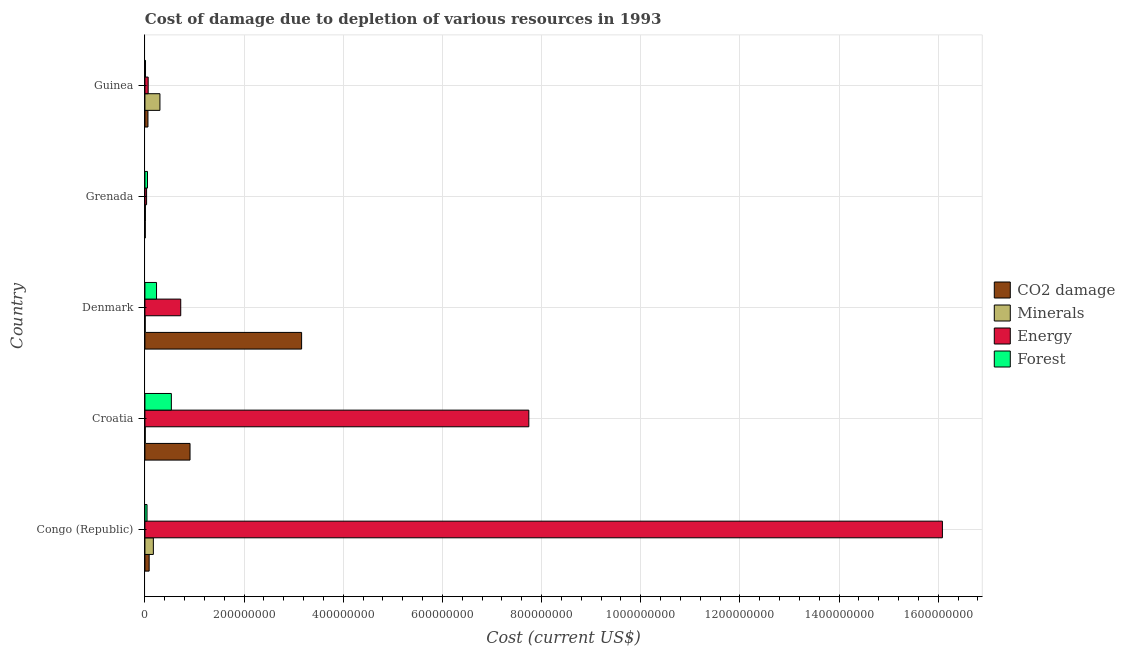How many groups of bars are there?
Provide a succinct answer. 5. Are the number of bars on each tick of the Y-axis equal?
Provide a succinct answer. Yes. How many bars are there on the 2nd tick from the top?
Provide a succinct answer. 4. How many bars are there on the 3rd tick from the bottom?
Offer a very short reply. 4. What is the label of the 5th group of bars from the top?
Your answer should be very brief. Congo (Republic). In how many cases, is the number of bars for a given country not equal to the number of legend labels?
Make the answer very short. 0. What is the cost of damage due to depletion of energy in Denmark?
Provide a succinct answer. 7.22e+07. Across all countries, what is the maximum cost of damage due to depletion of forests?
Ensure brevity in your answer.  5.33e+07. Across all countries, what is the minimum cost of damage due to depletion of forests?
Ensure brevity in your answer.  1.22e+06. In which country was the cost of damage due to depletion of minerals maximum?
Provide a succinct answer. Guinea. In which country was the cost of damage due to depletion of minerals minimum?
Your response must be concise. Denmark. What is the total cost of damage due to depletion of energy in the graph?
Offer a very short reply. 2.46e+09. What is the difference between the cost of damage due to depletion of coal in Congo (Republic) and that in Denmark?
Your answer should be very brief. -3.07e+08. What is the difference between the cost of damage due to depletion of forests in Grenada and the cost of damage due to depletion of energy in Denmark?
Keep it short and to the point. -6.70e+07. What is the average cost of damage due to depletion of energy per country?
Offer a terse response. 4.93e+08. What is the difference between the cost of damage due to depletion of forests and cost of damage due to depletion of energy in Grenada?
Offer a very short reply. 1.84e+06. In how many countries, is the cost of damage due to depletion of coal greater than 1160000000 US$?
Ensure brevity in your answer.  0. What is the ratio of the cost of damage due to depletion of minerals in Congo (Republic) to that in Guinea?
Make the answer very short. 0.56. What is the difference between the highest and the second highest cost of damage due to depletion of coal?
Give a very brief answer. 2.25e+08. What is the difference between the highest and the lowest cost of damage due to depletion of coal?
Provide a succinct answer. 3.15e+08. In how many countries, is the cost of damage due to depletion of coal greater than the average cost of damage due to depletion of coal taken over all countries?
Offer a terse response. 2. Is the sum of the cost of damage due to depletion of minerals in Grenada and Guinea greater than the maximum cost of damage due to depletion of forests across all countries?
Give a very brief answer. No. Is it the case that in every country, the sum of the cost of damage due to depletion of energy and cost of damage due to depletion of minerals is greater than the sum of cost of damage due to depletion of forests and cost of damage due to depletion of coal?
Keep it short and to the point. No. What does the 3rd bar from the top in Guinea represents?
Your response must be concise. Minerals. What does the 4th bar from the bottom in Denmark represents?
Your response must be concise. Forest. Is it the case that in every country, the sum of the cost of damage due to depletion of coal and cost of damage due to depletion of minerals is greater than the cost of damage due to depletion of energy?
Provide a succinct answer. No. How many bars are there?
Provide a short and direct response. 20. How many countries are there in the graph?
Provide a short and direct response. 5. Are the values on the major ticks of X-axis written in scientific E-notation?
Your answer should be compact. No. Does the graph contain any zero values?
Give a very brief answer. No. Does the graph contain grids?
Make the answer very short. Yes. How are the legend labels stacked?
Keep it short and to the point. Vertical. What is the title of the graph?
Keep it short and to the point. Cost of damage due to depletion of various resources in 1993 . What is the label or title of the X-axis?
Your answer should be compact. Cost (current US$). What is the label or title of the Y-axis?
Keep it short and to the point. Country. What is the Cost (current US$) in CO2 damage in Congo (Republic)?
Your answer should be compact. 8.55e+06. What is the Cost (current US$) in Minerals in Congo (Republic)?
Provide a succinct answer. 1.70e+07. What is the Cost (current US$) of Energy in Congo (Republic)?
Make the answer very short. 1.61e+09. What is the Cost (current US$) of Forest in Congo (Republic)?
Offer a very short reply. 4.27e+06. What is the Cost (current US$) of CO2 damage in Croatia?
Your answer should be very brief. 9.10e+07. What is the Cost (current US$) of Minerals in Croatia?
Keep it short and to the point. 6.66e+05. What is the Cost (current US$) of Energy in Croatia?
Offer a very short reply. 7.74e+08. What is the Cost (current US$) of Forest in Croatia?
Provide a short and direct response. 5.33e+07. What is the Cost (current US$) of CO2 damage in Denmark?
Your answer should be compact. 3.16e+08. What is the Cost (current US$) of Minerals in Denmark?
Give a very brief answer. 5.69e+05. What is the Cost (current US$) in Energy in Denmark?
Ensure brevity in your answer.  7.22e+07. What is the Cost (current US$) in Forest in Denmark?
Provide a succinct answer. 2.34e+07. What is the Cost (current US$) of CO2 damage in Grenada?
Provide a succinct answer. 6.90e+05. What is the Cost (current US$) of Minerals in Grenada?
Provide a short and direct response. 9.67e+05. What is the Cost (current US$) in Energy in Grenada?
Ensure brevity in your answer.  3.37e+06. What is the Cost (current US$) of Forest in Grenada?
Your answer should be compact. 5.21e+06. What is the Cost (current US$) in CO2 damage in Guinea?
Provide a short and direct response. 6.11e+06. What is the Cost (current US$) in Minerals in Guinea?
Provide a succinct answer. 3.03e+07. What is the Cost (current US$) in Energy in Guinea?
Your answer should be very brief. 6.56e+06. What is the Cost (current US$) of Forest in Guinea?
Make the answer very short. 1.22e+06. Across all countries, what is the maximum Cost (current US$) of CO2 damage?
Make the answer very short. 3.16e+08. Across all countries, what is the maximum Cost (current US$) in Minerals?
Make the answer very short. 3.03e+07. Across all countries, what is the maximum Cost (current US$) of Energy?
Your answer should be compact. 1.61e+09. Across all countries, what is the maximum Cost (current US$) in Forest?
Provide a short and direct response. 5.33e+07. Across all countries, what is the minimum Cost (current US$) of CO2 damage?
Provide a short and direct response. 6.90e+05. Across all countries, what is the minimum Cost (current US$) of Minerals?
Offer a terse response. 5.69e+05. Across all countries, what is the minimum Cost (current US$) in Energy?
Provide a succinct answer. 3.37e+06. Across all countries, what is the minimum Cost (current US$) in Forest?
Make the answer very short. 1.22e+06. What is the total Cost (current US$) of CO2 damage in the graph?
Offer a very short reply. 4.22e+08. What is the total Cost (current US$) in Minerals in the graph?
Your answer should be compact. 4.95e+07. What is the total Cost (current US$) in Energy in the graph?
Provide a short and direct response. 2.46e+09. What is the total Cost (current US$) in Forest in the graph?
Keep it short and to the point. 8.74e+07. What is the difference between the Cost (current US$) of CO2 damage in Congo (Republic) and that in Croatia?
Keep it short and to the point. -8.24e+07. What is the difference between the Cost (current US$) of Minerals in Congo (Republic) and that in Croatia?
Give a very brief answer. 1.63e+07. What is the difference between the Cost (current US$) in Energy in Congo (Republic) and that in Croatia?
Make the answer very short. 8.34e+08. What is the difference between the Cost (current US$) of Forest in Congo (Republic) and that in Croatia?
Make the answer very short. -4.90e+07. What is the difference between the Cost (current US$) in CO2 damage in Congo (Republic) and that in Denmark?
Keep it short and to the point. -3.07e+08. What is the difference between the Cost (current US$) in Minerals in Congo (Republic) and that in Denmark?
Ensure brevity in your answer.  1.64e+07. What is the difference between the Cost (current US$) of Energy in Congo (Republic) and that in Denmark?
Your answer should be very brief. 1.54e+09. What is the difference between the Cost (current US$) of Forest in Congo (Republic) and that in Denmark?
Provide a succinct answer. -1.91e+07. What is the difference between the Cost (current US$) in CO2 damage in Congo (Republic) and that in Grenada?
Provide a succinct answer. 7.86e+06. What is the difference between the Cost (current US$) in Minerals in Congo (Republic) and that in Grenada?
Keep it short and to the point. 1.60e+07. What is the difference between the Cost (current US$) of Energy in Congo (Republic) and that in Grenada?
Give a very brief answer. 1.60e+09. What is the difference between the Cost (current US$) in Forest in Congo (Republic) and that in Grenada?
Offer a terse response. -9.36e+05. What is the difference between the Cost (current US$) of CO2 damage in Congo (Republic) and that in Guinea?
Your answer should be compact. 2.44e+06. What is the difference between the Cost (current US$) in Minerals in Congo (Republic) and that in Guinea?
Your answer should be very brief. -1.33e+07. What is the difference between the Cost (current US$) of Energy in Congo (Republic) and that in Guinea?
Provide a short and direct response. 1.60e+09. What is the difference between the Cost (current US$) of Forest in Congo (Republic) and that in Guinea?
Give a very brief answer. 3.06e+06. What is the difference between the Cost (current US$) of CO2 damage in Croatia and that in Denmark?
Provide a succinct answer. -2.25e+08. What is the difference between the Cost (current US$) of Minerals in Croatia and that in Denmark?
Provide a succinct answer. 9.76e+04. What is the difference between the Cost (current US$) in Energy in Croatia and that in Denmark?
Your answer should be compact. 7.02e+08. What is the difference between the Cost (current US$) of Forest in Croatia and that in Denmark?
Ensure brevity in your answer.  2.99e+07. What is the difference between the Cost (current US$) in CO2 damage in Croatia and that in Grenada?
Make the answer very short. 9.03e+07. What is the difference between the Cost (current US$) of Minerals in Croatia and that in Grenada?
Give a very brief answer. -3.01e+05. What is the difference between the Cost (current US$) of Energy in Croatia and that in Grenada?
Offer a very short reply. 7.71e+08. What is the difference between the Cost (current US$) of Forest in Croatia and that in Grenada?
Provide a short and direct response. 4.81e+07. What is the difference between the Cost (current US$) of CO2 damage in Croatia and that in Guinea?
Make the answer very short. 8.49e+07. What is the difference between the Cost (current US$) of Minerals in Croatia and that in Guinea?
Offer a terse response. -2.96e+07. What is the difference between the Cost (current US$) in Energy in Croatia and that in Guinea?
Your answer should be very brief. 7.68e+08. What is the difference between the Cost (current US$) in Forest in Croatia and that in Guinea?
Provide a succinct answer. 5.21e+07. What is the difference between the Cost (current US$) in CO2 damage in Denmark and that in Grenada?
Offer a terse response. 3.15e+08. What is the difference between the Cost (current US$) in Minerals in Denmark and that in Grenada?
Offer a very short reply. -3.98e+05. What is the difference between the Cost (current US$) of Energy in Denmark and that in Grenada?
Keep it short and to the point. 6.89e+07. What is the difference between the Cost (current US$) in Forest in Denmark and that in Grenada?
Give a very brief answer. 1.82e+07. What is the difference between the Cost (current US$) in CO2 damage in Denmark and that in Guinea?
Ensure brevity in your answer.  3.10e+08. What is the difference between the Cost (current US$) in Minerals in Denmark and that in Guinea?
Make the answer very short. -2.97e+07. What is the difference between the Cost (current US$) in Energy in Denmark and that in Guinea?
Keep it short and to the point. 6.57e+07. What is the difference between the Cost (current US$) of Forest in Denmark and that in Guinea?
Give a very brief answer. 2.22e+07. What is the difference between the Cost (current US$) in CO2 damage in Grenada and that in Guinea?
Make the answer very short. -5.42e+06. What is the difference between the Cost (current US$) of Minerals in Grenada and that in Guinea?
Your answer should be very brief. -2.93e+07. What is the difference between the Cost (current US$) in Energy in Grenada and that in Guinea?
Your answer should be compact. -3.19e+06. What is the difference between the Cost (current US$) in Forest in Grenada and that in Guinea?
Your answer should be very brief. 3.99e+06. What is the difference between the Cost (current US$) of CO2 damage in Congo (Republic) and the Cost (current US$) of Minerals in Croatia?
Make the answer very short. 7.88e+06. What is the difference between the Cost (current US$) in CO2 damage in Congo (Republic) and the Cost (current US$) in Energy in Croatia?
Offer a terse response. -7.66e+08. What is the difference between the Cost (current US$) in CO2 damage in Congo (Republic) and the Cost (current US$) in Forest in Croatia?
Your answer should be very brief. -4.48e+07. What is the difference between the Cost (current US$) in Minerals in Congo (Republic) and the Cost (current US$) in Energy in Croatia?
Your answer should be very brief. -7.57e+08. What is the difference between the Cost (current US$) of Minerals in Congo (Republic) and the Cost (current US$) of Forest in Croatia?
Make the answer very short. -3.63e+07. What is the difference between the Cost (current US$) of Energy in Congo (Republic) and the Cost (current US$) of Forest in Croatia?
Make the answer very short. 1.55e+09. What is the difference between the Cost (current US$) in CO2 damage in Congo (Republic) and the Cost (current US$) in Minerals in Denmark?
Provide a succinct answer. 7.98e+06. What is the difference between the Cost (current US$) in CO2 damage in Congo (Republic) and the Cost (current US$) in Energy in Denmark?
Provide a succinct answer. -6.37e+07. What is the difference between the Cost (current US$) in CO2 damage in Congo (Republic) and the Cost (current US$) in Forest in Denmark?
Give a very brief answer. -1.49e+07. What is the difference between the Cost (current US$) of Minerals in Congo (Republic) and the Cost (current US$) of Energy in Denmark?
Provide a short and direct response. -5.52e+07. What is the difference between the Cost (current US$) of Minerals in Congo (Republic) and the Cost (current US$) of Forest in Denmark?
Offer a very short reply. -6.41e+06. What is the difference between the Cost (current US$) of Energy in Congo (Republic) and the Cost (current US$) of Forest in Denmark?
Offer a terse response. 1.58e+09. What is the difference between the Cost (current US$) in CO2 damage in Congo (Republic) and the Cost (current US$) in Minerals in Grenada?
Give a very brief answer. 7.58e+06. What is the difference between the Cost (current US$) in CO2 damage in Congo (Republic) and the Cost (current US$) in Energy in Grenada?
Provide a short and direct response. 5.18e+06. What is the difference between the Cost (current US$) of CO2 damage in Congo (Republic) and the Cost (current US$) of Forest in Grenada?
Provide a short and direct response. 3.34e+06. What is the difference between the Cost (current US$) of Minerals in Congo (Republic) and the Cost (current US$) of Energy in Grenada?
Your answer should be compact. 1.36e+07. What is the difference between the Cost (current US$) of Minerals in Congo (Republic) and the Cost (current US$) of Forest in Grenada?
Your response must be concise. 1.18e+07. What is the difference between the Cost (current US$) of Energy in Congo (Republic) and the Cost (current US$) of Forest in Grenada?
Your answer should be very brief. 1.60e+09. What is the difference between the Cost (current US$) in CO2 damage in Congo (Republic) and the Cost (current US$) in Minerals in Guinea?
Offer a terse response. -2.17e+07. What is the difference between the Cost (current US$) of CO2 damage in Congo (Republic) and the Cost (current US$) of Energy in Guinea?
Keep it short and to the point. 1.99e+06. What is the difference between the Cost (current US$) in CO2 damage in Congo (Republic) and the Cost (current US$) in Forest in Guinea?
Offer a very short reply. 7.33e+06. What is the difference between the Cost (current US$) of Minerals in Congo (Republic) and the Cost (current US$) of Energy in Guinea?
Your answer should be compact. 1.04e+07. What is the difference between the Cost (current US$) in Minerals in Congo (Republic) and the Cost (current US$) in Forest in Guinea?
Offer a terse response. 1.58e+07. What is the difference between the Cost (current US$) in Energy in Congo (Republic) and the Cost (current US$) in Forest in Guinea?
Make the answer very short. 1.61e+09. What is the difference between the Cost (current US$) in CO2 damage in Croatia and the Cost (current US$) in Minerals in Denmark?
Provide a succinct answer. 9.04e+07. What is the difference between the Cost (current US$) in CO2 damage in Croatia and the Cost (current US$) in Energy in Denmark?
Ensure brevity in your answer.  1.87e+07. What is the difference between the Cost (current US$) in CO2 damage in Croatia and the Cost (current US$) in Forest in Denmark?
Offer a terse response. 6.76e+07. What is the difference between the Cost (current US$) of Minerals in Croatia and the Cost (current US$) of Energy in Denmark?
Your response must be concise. -7.16e+07. What is the difference between the Cost (current US$) in Minerals in Croatia and the Cost (current US$) in Forest in Denmark?
Ensure brevity in your answer.  -2.27e+07. What is the difference between the Cost (current US$) in Energy in Croatia and the Cost (current US$) in Forest in Denmark?
Your answer should be compact. 7.51e+08. What is the difference between the Cost (current US$) in CO2 damage in Croatia and the Cost (current US$) in Minerals in Grenada?
Keep it short and to the point. 9.00e+07. What is the difference between the Cost (current US$) in CO2 damage in Croatia and the Cost (current US$) in Energy in Grenada?
Your answer should be compact. 8.76e+07. What is the difference between the Cost (current US$) of CO2 damage in Croatia and the Cost (current US$) of Forest in Grenada?
Your answer should be compact. 8.58e+07. What is the difference between the Cost (current US$) in Minerals in Croatia and the Cost (current US$) in Energy in Grenada?
Keep it short and to the point. -2.70e+06. What is the difference between the Cost (current US$) in Minerals in Croatia and the Cost (current US$) in Forest in Grenada?
Offer a very short reply. -4.54e+06. What is the difference between the Cost (current US$) of Energy in Croatia and the Cost (current US$) of Forest in Grenada?
Offer a very short reply. 7.69e+08. What is the difference between the Cost (current US$) of CO2 damage in Croatia and the Cost (current US$) of Minerals in Guinea?
Your answer should be compact. 6.07e+07. What is the difference between the Cost (current US$) of CO2 damage in Croatia and the Cost (current US$) of Energy in Guinea?
Provide a succinct answer. 8.44e+07. What is the difference between the Cost (current US$) of CO2 damage in Croatia and the Cost (current US$) of Forest in Guinea?
Offer a terse response. 8.97e+07. What is the difference between the Cost (current US$) in Minerals in Croatia and the Cost (current US$) in Energy in Guinea?
Your answer should be compact. -5.89e+06. What is the difference between the Cost (current US$) of Minerals in Croatia and the Cost (current US$) of Forest in Guinea?
Keep it short and to the point. -5.52e+05. What is the difference between the Cost (current US$) of Energy in Croatia and the Cost (current US$) of Forest in Guinea?
Offer a very short reply. 7.73e+08. What is the difference between the Cost (current US$) of CO2 damage in Denmark and the Cost (current US$) of Minerals in Grenada?
Make the answer very short. 3.15e+08. What is the difference between the Cost (current US$) of CO2 damage in Denmark and the Cost (current US$) of Energy in Grenada?
Offer a very short reply. 3.13e+08. What is the difference between the Cost (current US$) in CO2 damage in Denmark and the Cost (current US$) in Forest in Grenada?
Offer a very short reply. 3.11e+08. What is the difference between the Cost (current US$) in Minerals in Denmark and the Cost (current US$) in Energy in Grenada?
Offer a terse response. -2.80e+06. What is the difference between the Cost (current US$) of Minerals in Denmark and the Cost (current US$) of Forest in Grenada?
Give a very brief answer. -4.64e+06. What is the difference between the Cost (current US$) in Energy in Denmark and the Cost (current US$) in Forest in Grenada?
Provide a succinct answer. 6.70e+07. What is the difference between the Cost (current US$) in CO2 damage in Denmark and the Cost (current US$) in Minerals in Guinea?
Ensure brevity in your answer.  2.86e+08. What is the difference between the Cost (current US$) of CO2 damage in Denmark and the Cost (current US$) of Energy in Guinea?
Keep it short and to the point. 3.09e+08. What is the difference between the Cost (current US$) of CO2 damage in Denmark and the Cost (current US$) of Forest in Guinea?
Ensure brevity in your answer.  3.15e+08. What is the difference between the Cost (current US$) in Minerals in Denmark and the Cost (current US$) in Energy in Guinea?
Offer a terse response. -5.99e+06. What is the difference between the Cost (current US$) of Minerals in Denmark and the Cost (current US$) of Forest in Guinea?
Your response must be concise. -6.49e+05. What is the difference between the Cost (current US$) of Energy in Denmark and the Cost (current US$) of Forest in Guinea?
Keep it short and to the point. 7.10e+07. What is the difference between the Cost (current US$) of CO2 damage in Grenada and the Cost (current US$) of Minerals in Guinea?
Provide a short and direct response. -2.96e+07. What is the difference between the Cost (current US$) in CO2 damage in Grenada and the Cost (current US$) in Energy in Guinea?
Your answer should be compact. -5.87e+06. What is the difference between the Cost (current US$) in CO2 damage in Grenada and the Cost (current US$) in Forest in Guinea?
Offer a terse response. -5.28e+05. What is the difference between the Cost (current US$) in Minerals in Grenada and the Cost (current US$) in Energy in Guinea?
Ensure brevity in your answer.  -5.59e+06. What is the difference between the Cost (current US$) of Minerals in Grenada and the Cost (current US$) of Forest in Guinea?
Your answer should be compact. -2.51e+05. What is the difference between the Cost (current US$) of Energy in Grenada and the Cost (current US$) of Forest in Guinea?
Offer a very short reply. 2.15e+06. What is the average Cost (current US$) of CO2 damage per country?
Provide a short and direct response. 8.45e+07. What is the average Cost (current US$) of Minerals per country?
Offer a very short reply. 9.90e+06. What is the average Cost (current US$) of Energy per country?
Keep it short and to the point. 4.93e+08. What is the average Cost (current US$) in Forest per country?
Offer a very short reply. 1.75e+07. What is the difference between the Cost (current US$) in CO2 damage and Cost (current US$) in Minerals in Congo (Republic)?
Your answer should be very brief. -8.46e+06. What is the difference between the Cost (current US$) of CO2 damage and Cost (current US$) of Energy in Congo (Republic)?
Your response must be concise. -1.60e+09. What is the difference between the Cost (current US$) in CO2 damage and Cost (current US$) in Forest in Congo (Republic)?
Offer a very short reply. 4.27e+06. What is the difference between the Cost (current US$) in Minerals and Cost (current US$) in Energy in Congo (Republic)?
Keep it short and to the point. -1.59e+09. What is the difference between the Cost (current US$) of Minerals and Cost (current US$) of Forest in Congo (Republic)?
Offer a terse response. 1.27e+07. What is the difference between the Cost (current US$) of Energy and Cost (current US$) of Forest in Congo (Republic)?
Your answer should be very brief. 1.60e+09. What is the difference between the Cost (current US$) of CO2 damage and Cost (current US$) of Minerals in Croatia?
Offer a terse response. 9.03e+07. What is the difference between the Cost (current US$) of CO2 damage and Cost (current US$) of Energy in Croatia?
Provide a succinct answer. -6.83e+08. What is the difference between the Cost (current US$) in CO2 damage and Cost (current US$) in Forest in Croatia?
Offer a terse response. 3.77e+07. What is the difference between the Cost (current US$) of Minerals and Cost (current US$) of Energy in Croatia?
Provide a succinct answer. -7.74e+08. What is the difference between the Cost (current US$) of Minerals and Cost (current US$) of Forest in Croatia?
Offer a terse response. -5.26e+07. What is the difference between the Cost (current US$) of Energy and Cost (current US$) of Forest in Croatia?
Keep it short and to the point. 7.21e+08. What is the difference between the Cost (current US$) in CO2 damage and Cost (current US$) in Minerals in Denmark?
Provide a short and direct response. 3.15e+08. What is the difference between the Cost (current US$) in CO2 damage and Cost (current US$) in Energy in Denmark?
Your answer should be compact. 2.44e+08. What is the difference between the Cost (current US$) of CO2 damage and Cost (current US$) of Forest in Denmark?
Ensure brevity in your answer.  2.93e+08. What is the difference between the Cost (current US$) of Minerals and Cost (current US$) of Energy in Denmark?
Offer a terse response. -7.17e+07. What is the difference between the Cost (current US$) in Minerals and Cost (current US$) in Forest in Denmark?
Keep it short and to the point. -2.28e+07. What is the difference between the Cost (current US$) of Energy and Cost (current US$) of Forest in Denmark?
Provide a succinct answer. 4.88e+07. What is the difference between the Cost (current US$) in CO2 damage and Cost (current US$) in Minerals in Grenada?
Provide a short and direct response. -2.77e+05. What is the difference between the Cost (current US$) in CO2 damage and Cost (current US$) in Energy in Grenada?
Your answer should be very brief. -2.68e+06. What is the difference between the Cost (current US$) in CO2 damage and Cost (current US$) in Forest in Grenada?
Keep it short and to the point. -4.52e+06. What is the difference between the Cost (current US$) of Minerals and Cost (current US$) of Energy in Grenada?
Your response must be concise. -2.40e+06. What is the difference between the Cost (current US$) of Minerals and Cost (current US$) of Forest in Grenada?
Your response must be concise. -4.24e+06. What is the difference between the Cost (current US$) of Energy and Cost (current US$) of Forest in Grenada?
Give a very brief answer. -1.84e+06. What is the difference between the Cost (current US$) of CO2 damage and Cost (current US$) of Minerals in Guinea?
Provide a short and direct response. -2.42e+07. What is the difference between the Cost (current US$) in CO2 damage and Cost (current US$) in Energy in Guinea?
Your answer should be very brief. -4.44e+05. What is the difference between the Cost (current US$) of CO2 damage and Cost (current US$) of Forest in Guinea?
Provide a short and direct response. 4.89e+06. What is the difference between the Cost (current US$) of Minerals and Cost (current US$) of Energy in Guinea?
Offer a terse response. 2.37e+07. What is the difference between the Cost (current US$) of Minerals and Cost (current US$) of Forest in Guinea?
Ensure brevity in your answer.  2.91e+07. What is the difference between the Cost (current US$) of Energy and Cost (current US$) of Forest in Guinea?
Your answer should be compact. 5.34e+06. What is the ratio of the Cost (current US$) in CO2 damage in Congo (Republic) to that in Croatia?
Provide a succinct answer. 0.09. What is the ratio of the Cost (current US$) in Minerals in Congo (Republic) to that in Croatia?
Offer a terse response. 25.52. What is the ratio of the Cost (current US$) in Energy in Congo (Republic) to that in Croatia?
Provide a short and direct response. 2.08. What is the ratio of the Cost (current US$) in Forest in Congo (Republic) to that in Croatia?
Give a very brief answer. 0.08. What is the ratio of the Cost (current US$) in CO2 damage in Congo (Republic) to that in Denmark?
Provide a short and direct response. 0.03. What is the ratio of the Cost (current US$) in Minerals in Congo (Republic) to that in Denmark?
Give a very brief answer. 29.9. What is the ratio of the Cost (current US$) in Energy in Congo (Republic) to that in Denmark?
Your response must be concise. 22.26. What is the ratio of the Cost (current US$) in Forest in Congo (Republic) to that in Denmark?
Offer a terse response. 0.18. What is the ratio of the Cost (current US$) of CO2 damage in Congo (Republic) to that in Grenada?
Make the answer very short. 12.38. What is the ratio of the Cost (current US$) of Minerals in Congo (Republic) to that in Grenada?
Ensure brevity in your answer.  17.59. What is the ratio of the Cost (current US$) in Energy in Congo (Republic) to that in Grenada?
Make the answer very short. 477.57. What is the ratio of the Cost (current US$) in Forest in Congo (Republic) to that in Grenada?
Give a very brief answer. 0.82. What is the ratio of the Cost (current US$) of CO2 damage in Congo (Republic) to that in Guinea?
Give a very brief answer. 1.4. What is the ratio of the Cost (current US$) of Minerals in Congo (Republic) to that in Guinea?
Ensure brevity in your answer.  0.56. What is the ratio of the Cost (current US$) of Energy in Congo (Republic) to that in Guinea?
Provide a short and direct response. 245.32. What is the ratio of the Cost (current US$) of Forest in Congo (Republic) to that in Guinea?
Give a very brief answer. 3.51. What is the ratio of the Cost (current US$) in CO2 damage in Croatia to that in Denmark?
Offer a terse response. 0.29. What is the ratio of the Cost (current US$) of Minerals in Croatia to that in Denmark?
Your response must be concise. 1.17. What is the ratio of the Cost (current US$) in Energy in Croatia to that in Denmark?
Make the answer very short. 10.72. What is the ratio of the Cost (current US$) of Forest in Croatia to that in Denmark?
Your answer should be compact. 2.28. What is the ratio of the Cost (current US$) in CO2 damage in Croatia to that in Grenada?
Your answer should be compact. 131.76. What is the ratio of the Cost (current US$) of Minerals in Croatia to that in Grenada?
Offer a very short reply. 0.69. What is the ratio of the Cost (current US$) of Energy in Croatia to that in Grenada?
Provide a short and direct response. 229.9. What is the ratio of the Cost (current US$) in Forest in Croatia to that in Grenada?
Your answer should be very brief. 10.23. What is the ratio of the Cost (current US$) of CO2 damage in Croatia to that in Guinea?
Give a very brief answer. 14.88. What is the ratio of the Cost (current US$) in Minerals in Croatia to that in Guinea?
Your answer should be very brief. 0.02. What is the ratio of the Cost (current US$) in Energy in Croatia to that in Guinea?
Your answer should be very brief. 118.1. What is the ratio of the Cost (current US$) of Forest in Croatia to that in Guinea?
Provide a short and direct response. 43.76. What is the ratio of the Cost (current US$) in CO2 damage in Denmark to that in Grenada?
Provide a succinct answer. 457.71. What is the ratio of the Cost (current US$) of Minerals in Denmark to that in Grenada?
Make the answer very short. 0.59. What is the ratio of the Cost (current US$) in Energy in Denmark to that in Grenada?
Ensure brevity in your answer.  21.45. What is the ratio of the Cost (current US$) of Forest in Denmark to that in Grenada?
Make the answer very short. 4.49. What is the ratio of the Cost (current US$) of CO2 damage in Denmark to that in Guinea?
Give a very brief answer. 51.7. What is the ratio of the Cost (current US$) of Minerals in Denmark to that in Guinea?
Your response must be concise. 0.02. What is the ratio of the Cost (current US$) in Energy in Denmark to that in Guinea?
Provide a short and direct response. 11.02. What is the ratio of the Cost (current US$) of Forest in Denmark to that in Guinea?
Give a very brief answer. 19.22. What is the ratio of the Cost (current US$) in CO2 damage in Grenada to that in Guinea?
Provide a succinct answer. 0.11. What is the ratio of the Cost (current US$) in Minerals in Grenada to that in Guinea?
Provide a succinct answer. 0.03. What is the ratio of the Cost (current US$) of Energy in Grenada to that in Guinea?
Make the answer very short. 0.51. What is the ratio of the Cost (current US$) in Forest in Grenada to that in Guinea?
Give a very brief answer. 4.28. What is the difference between the highest and the second highest Cost (current US$) in CO2 damage?
Offer a very short reply. 2.25e+08. What is the difference between the highest and the second highest Cost (current US$) of Minerals?
Keep it short and to the point. 1.33e+07. What is the difference between the highest and the second highest Cost (current US$) in Energy?
Keep it short and to the point. 8.34e+08. What is the difference between the highest and the second highest Cost (current US$) of Forest?
Give a very brief answer. 2.99e+07. What is the difference between the highest and the lowest Cost (current US$) of CO2 damage?
Your answer should be very brief. 3.15e+08. What is the difference between the highest and the lowest Cost (current US$) in Minerals?
Your response must be concise. 2.97e+07. What is the difference between the highest and the lowest Cost (current US$) in Energy?
Ensure brevity in your answer.  1.60e+09. What is the difference between the highest and the lowest Cost (current US$) in Forest?
Provide a short and direct response. 5.21e+07. 